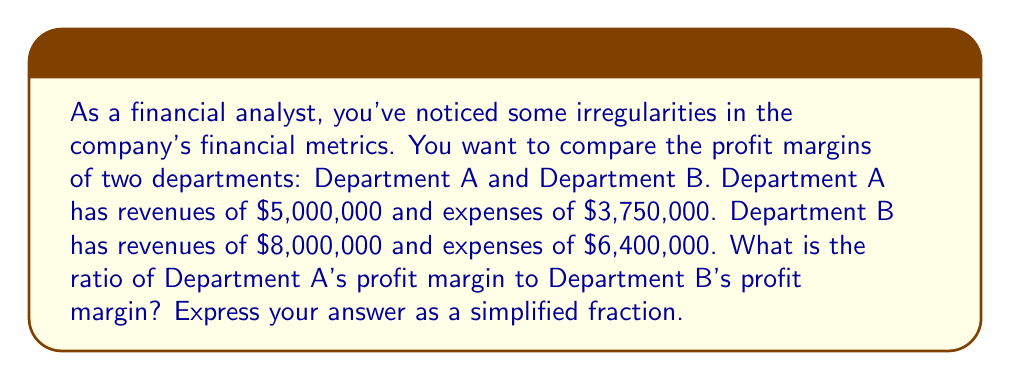Provide a solution to this math problem. To solve this problem, we need to follow these steps:

1. Calculate the profit margin for each department:
   Profit Margin = (Revenue - Expenses) / Revenue

2. For Department A:
   Profit Margin A = $(5,000,000 - 3,750,000) / 5,000,000$
                   = $1,250,000 / 5,000,000$
                   = $0.25$ or $25\%$

3. For Department B:
   Profit Margin B = $(8,000,000 - 6,400,000) / 8,000,000$
                   = $1,600,000 / 8,000,000$
                   = $0.20$ or $20\%$

4. Now, we need to find the ratio of these profit margins:
   Ratio = Profit Margin A : Profit Margin B
         = $0.25 : 0.20$

5. To simplify this ratio, we can divide both numbers by their greatest common divisor (GCD):
   $GCD(25, 20) = 5$

   $0.25 / 0.05 : 0.20 / 0.05$
   = $5 : 4$

Therefore, the ratio of Department A's profit margin to Department B's profit margin is $5:4$ or $5/4$ when expressed as a fraction.
Answer: $\frac{5}{4}$ 